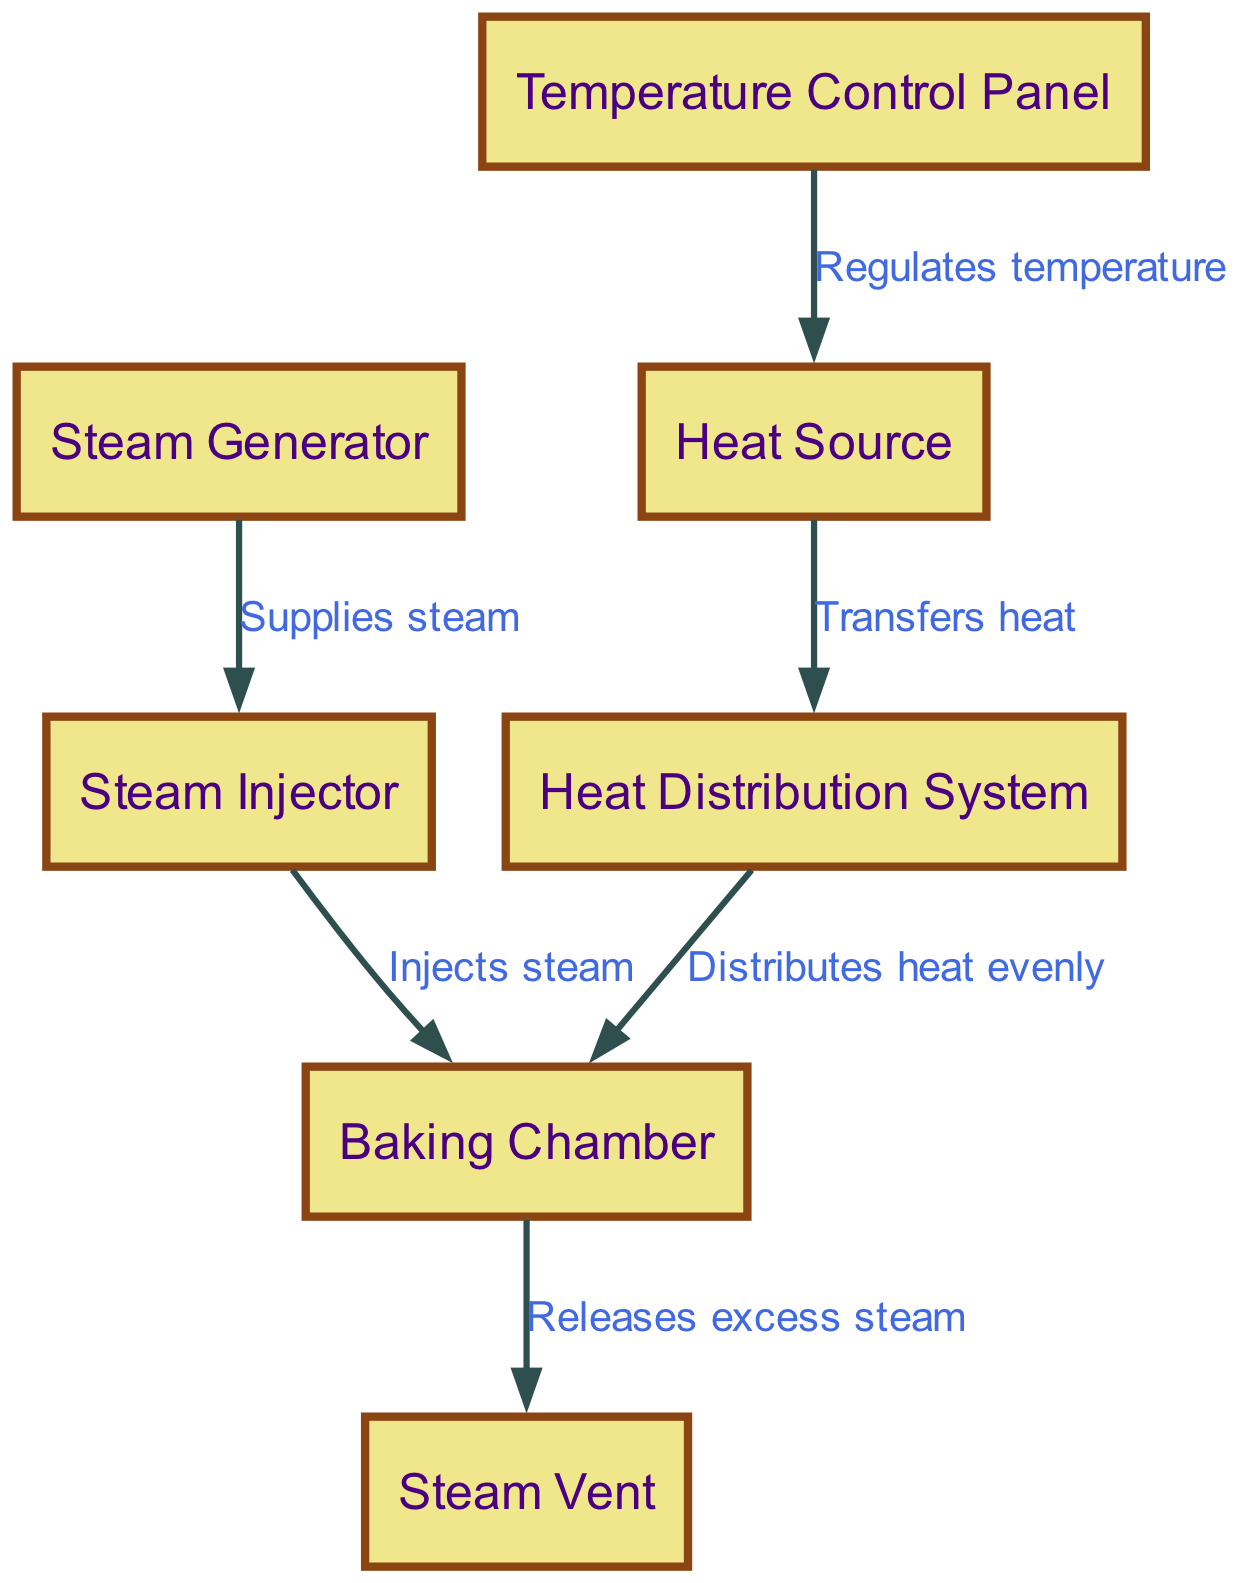What is the central component where the baking occurs? The diagram indicates that the central component for baking in the oven is labeled "Baking Chamber." This node is directly where all the processes converge to create the finish product.
Answer: Baking Chamber How many nodes are in the diagram? Upon reviewing the diagram's listed nodes, there are a total of six distinct nodes present: Baking Chamber, Heat Source, Steam Generator, Temperature Control Panel, Steam Injector, and Heat Distribution System. Count them to verify.
Answer: Six What does the steam injector do? The diagram shows a clear connection arrow from the Steam Injector leading to the Baking Chamber with the label "Injects steam." This label indicates the function of the steam injector in the process of baking.
Answer: Injects steam Which node regulates the temperature? The arrow leads from the Temperature Control Panel to the Heat Source and is labeled "Regulates temperature." Thus, the Temperature Control Panel is responsible for adjusting the heat levels within the oven.
Answer: Temperature Control Panel What is the relationship between the heat source and the heat distribution system? The diagram illustrates a direct edge from the Heat Source to the Heat Distribution System, labeled "Transfers heat." This relationship elucidates the pathway of heat being transferred to ensure even baking.
Answer: Transfers heat How does excess steam escape from the oven? The connection from the Baking Chamber to the Steam Vent is marked "Releases excess steam," indicating that the steam vent serves the function of letting out any steam that exceeds the chamber’s capacity.
Answer: Releases excess steam What supplies steam to the steam injector? The diagram indicates that the Steam Generator supplies steam to the Steam Injector through a directed edge labeled "Supplies steam." Thus, the Steam Generator is responsible for producing the steam needed.
Answer: Supplies steam How are heat and steam connected in this oven system? Heat is transferred from the Heat Source through the Heat Distribution System to the Baking Chamber, while steam is injected from the Steam Injector, which receives steam from the Steam Generator. These systems work concurrently to create optimal baking conditions.
Answer: Concurrently How many edges connect the nodes? By examining the connections (edges) between the nodes in the diagram, we see there are a total of six edges that describe interactions between different components of the oven system. Verifying these will provide the total.
Answer: Six 